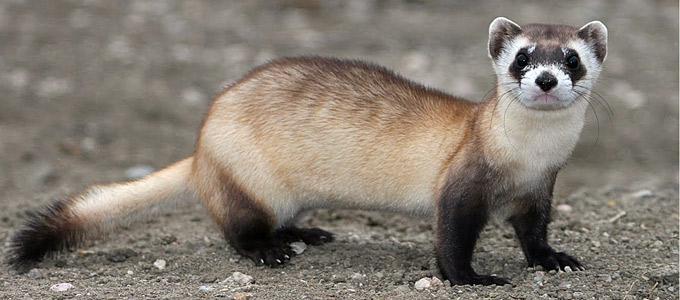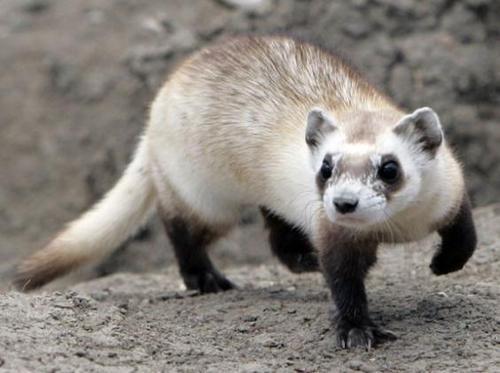The first image is the image on the left, the second image is the image on the right. Analyze the images presented: Is the assertion "There are exactly two animals in the image on the left." valid? Answer yes or no. No. 